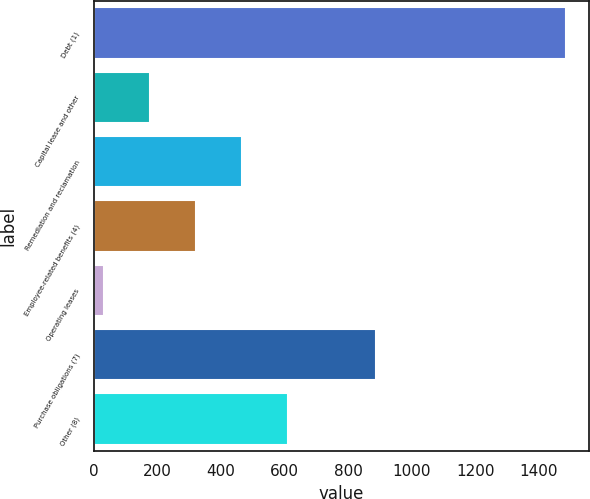Convert chart. <chart><loc_0><loc_0><loc_500><loc_500><bar_chart><fcel>Debt (1)<fcel>Capital lease and other<fcel>Remediation and reclamation<fcel>Employee-related benefits (4)<fcel>Operating leases<fcel>Purchase obligations (7)<fcel>Other (8)<nl><fcel>1484<fcel>175.4<fcel>466.2<fcel>320.8<fcel>30<fcel>887<fcel>611.6<nl></chart> 